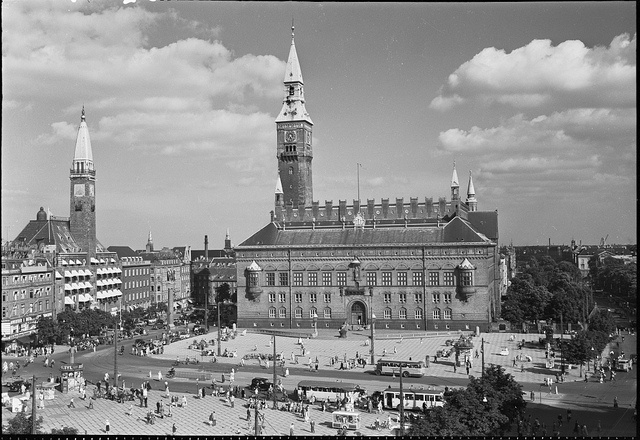Describe the objects in this image and their specific colors. I can see people in black, darkgray, gray, and lightgray tones, bus in black, gray, darkgray, and lightgray tones, bus in black, lightgray, gray, and darkgray tones, bus in black, darkgray, gray, and lightgray tones, and car in black, gray, darkgray, and lightgray tones in this image. 